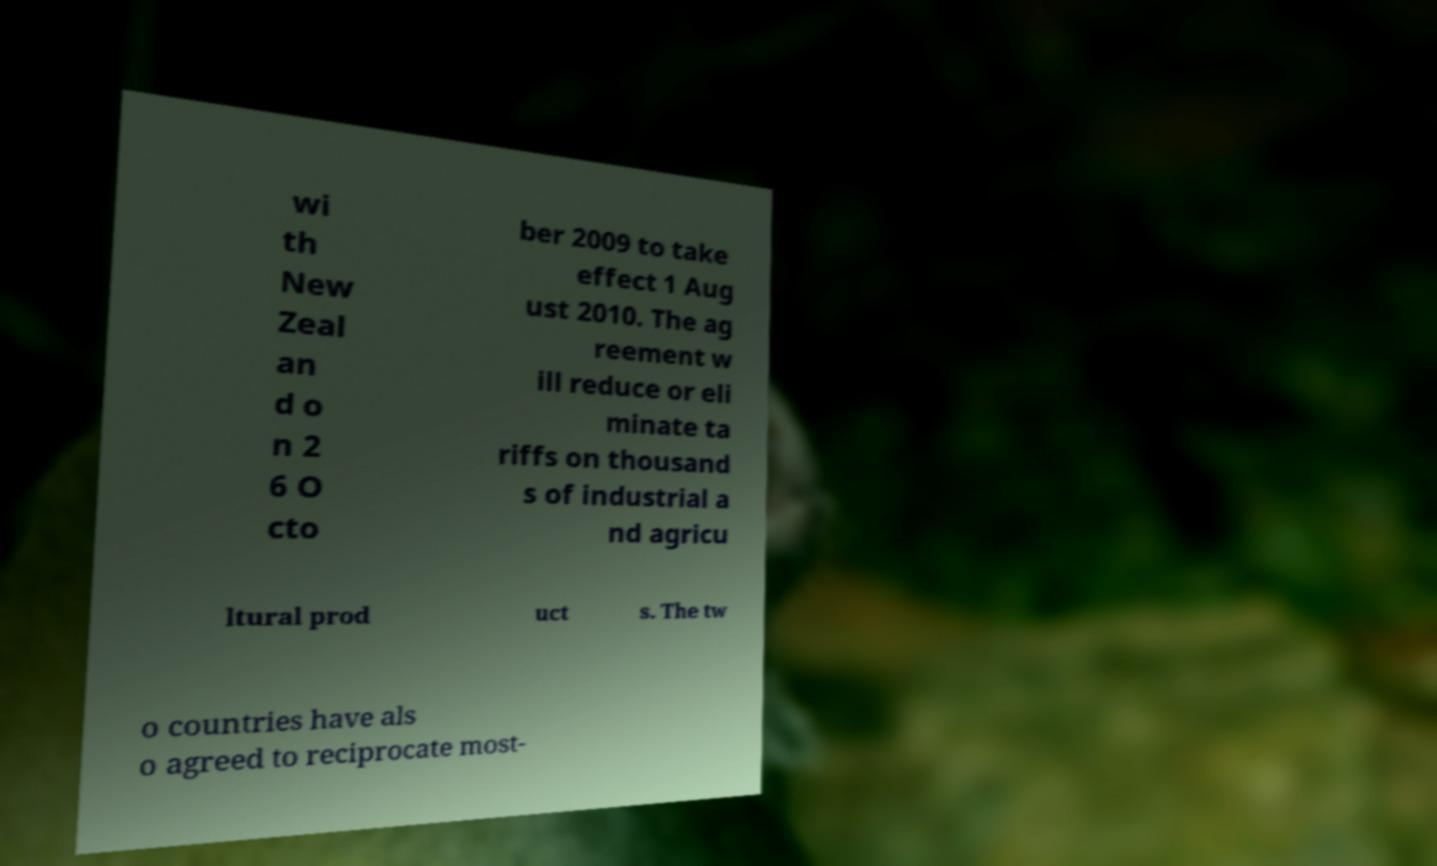There's text embedded in this image that I need extracted. Can you transcribe it verbatim? wi th New Zeal an d o n 2 6 O cto ber 2009 to take effect 1 Aug ust 2010. The ag reement w ill reduce or eli minate ta riffs on thousand s of industrial a nd agricu ltural prod uct s. The tw o countries have als o agreed to reciprocate most- 